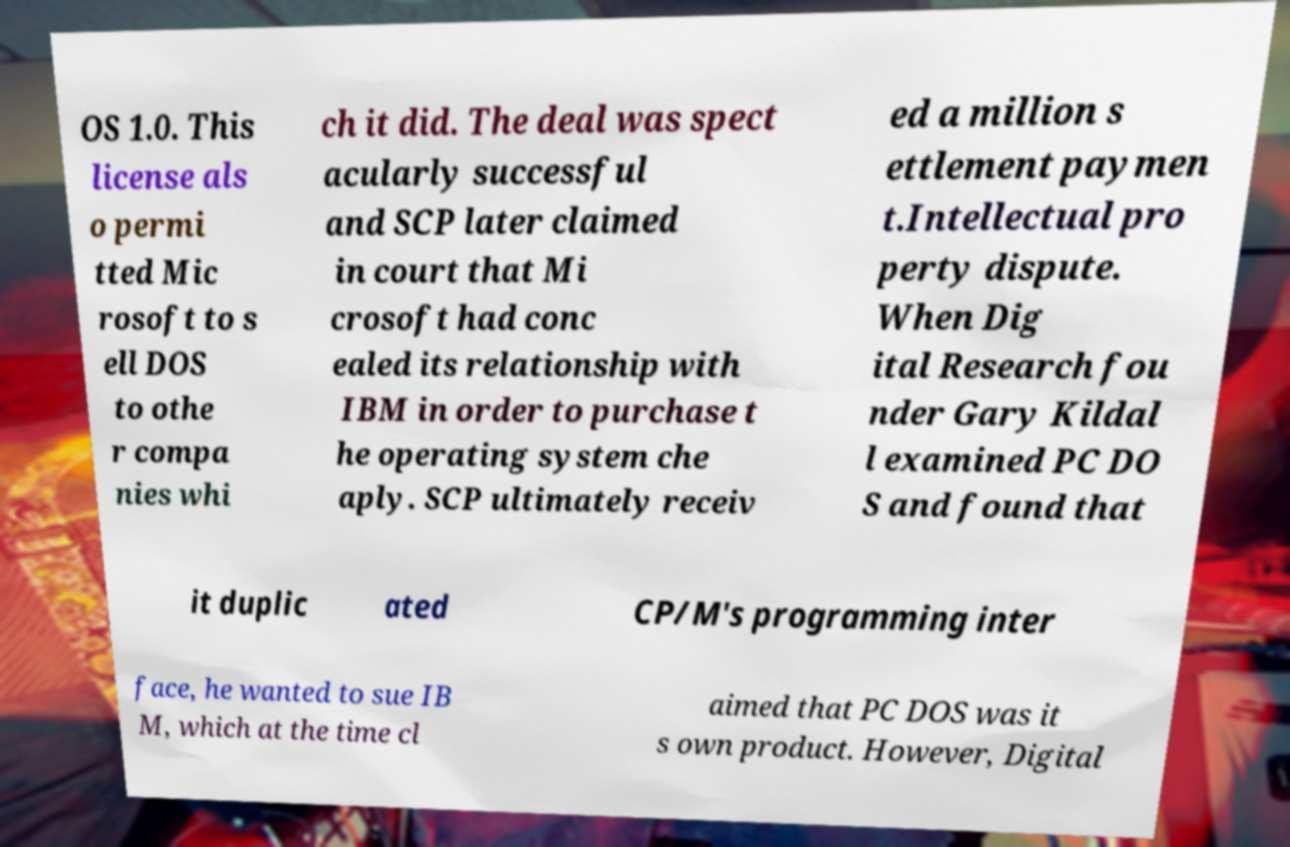For documentation purposes, I need the text within this image transcribed. Could you provide that? OS 1.0. This license als o permi tted Mic rosoft to s ell DOS to othe r compa nies whi ch it did. The deal was spect acularly successful and SCP later claimed in court that Mi crosoft had conc ealed its relationship with IBM in order to purchase t he operating system che aply. SCP ultimately receiv ed a million s ettlement paymen t.Intellectual pro perty dispute. When Dig ital Research fou nder Gary Kildal l examined PC DO S and found that it duplic ated CP/M's programming inter face, he wanted to sue IB M, which at the time cl aimed that PC DOS was it s own product. However, Digital 